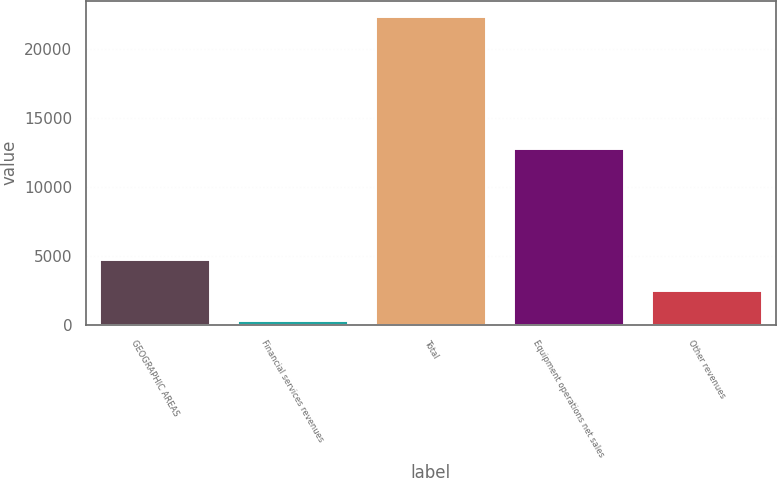Convert chart to OTSL. <chart><loc_0><loc_0><loc_500><loc_500><bar_chart><fcel>GEOGRAPHIC AREAS<fcel>Financial services revenues<fcel>Total<fcel>Equipment operations net sales<fcel>Other revenues<nl><fcel>4763.8<fcel>357<fcel>22391<fcel>12790<fcel>2560.4<nl></chart> 